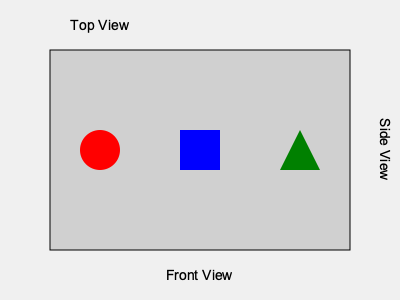As a guitarist familiar with stage setups, which perspective view would show the drum kit (represented by the blue square) appearing larger than the guitar amp (red circle) and the bass amp (green triangle)? To answer this question, we need to consider the relative positions and sizes of the objects on stage from different perspectives:

1. Front View: From this angle, all objects would appear in a line, with their relative sizes determined by their distance from the front of the stage. The drum kit (blue square) is positioned in the center, so it might appear similar in size to the other equipment.

2. Top View: This perspective would show the layout of the equipment from above, but wouldn't give a clear indication of height or perceived size from the audience's perspective.

3. Side View: This is the key perspective for this question. From the side:
   a) The guitar amp (red circle) is positioned at the front of the stage.
   b) The drum kit (blue square) is in the middle.
   c) The bass amp (green triangle) is at the back.

In a side view, objects farther away from the viewpoint appear larger. Therefore, the drum kit would appear larger than the guitar amp in front of it. The bass amp, being farthest back, would appear smallest from this angle.

Given the guitarist's experience with stage setups, they should recognize that the side view is the perspective where the drum kit would appear larger than both the guitar and bass amps.
Answer: Side View 